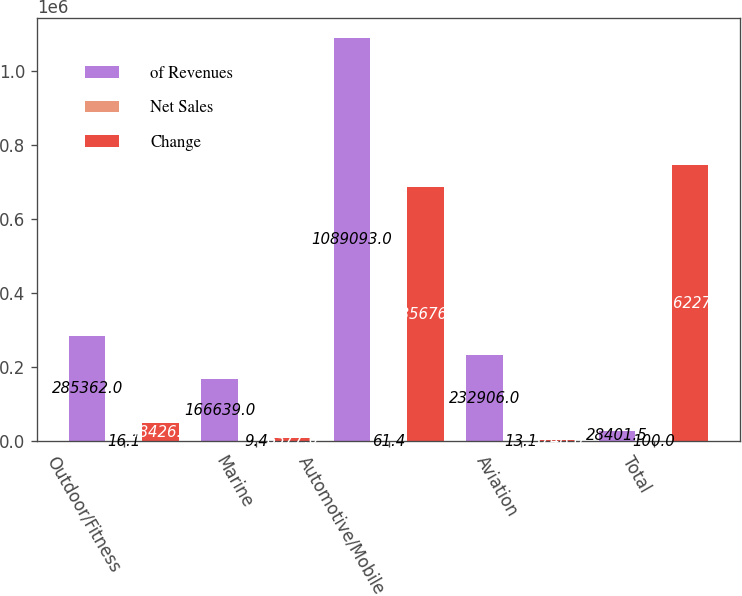<chart> <loc_0><loc_0><loc_500><loc_500><stacked_bar_chart><ecel><fcel>Outdoor/Fitness<fcel>Marine<fcel>Automotive/Mobile<fcel>Aviation<fcel>Total<nl><fcel>of Revenues<fcel>285362<fcel>166639<fcel>1.08909e+06<fcel>232906<fcel>28401.5<nl><fcel>Net Sales<fcel>16.1<fcel>9.4<fcel>61.4<fcel>13.1<fcel>100<nl><fcel>Change<fcel>48426<fcel>8377<fcel>685676<fcel>3748<fcel>746227<nl></chart> 